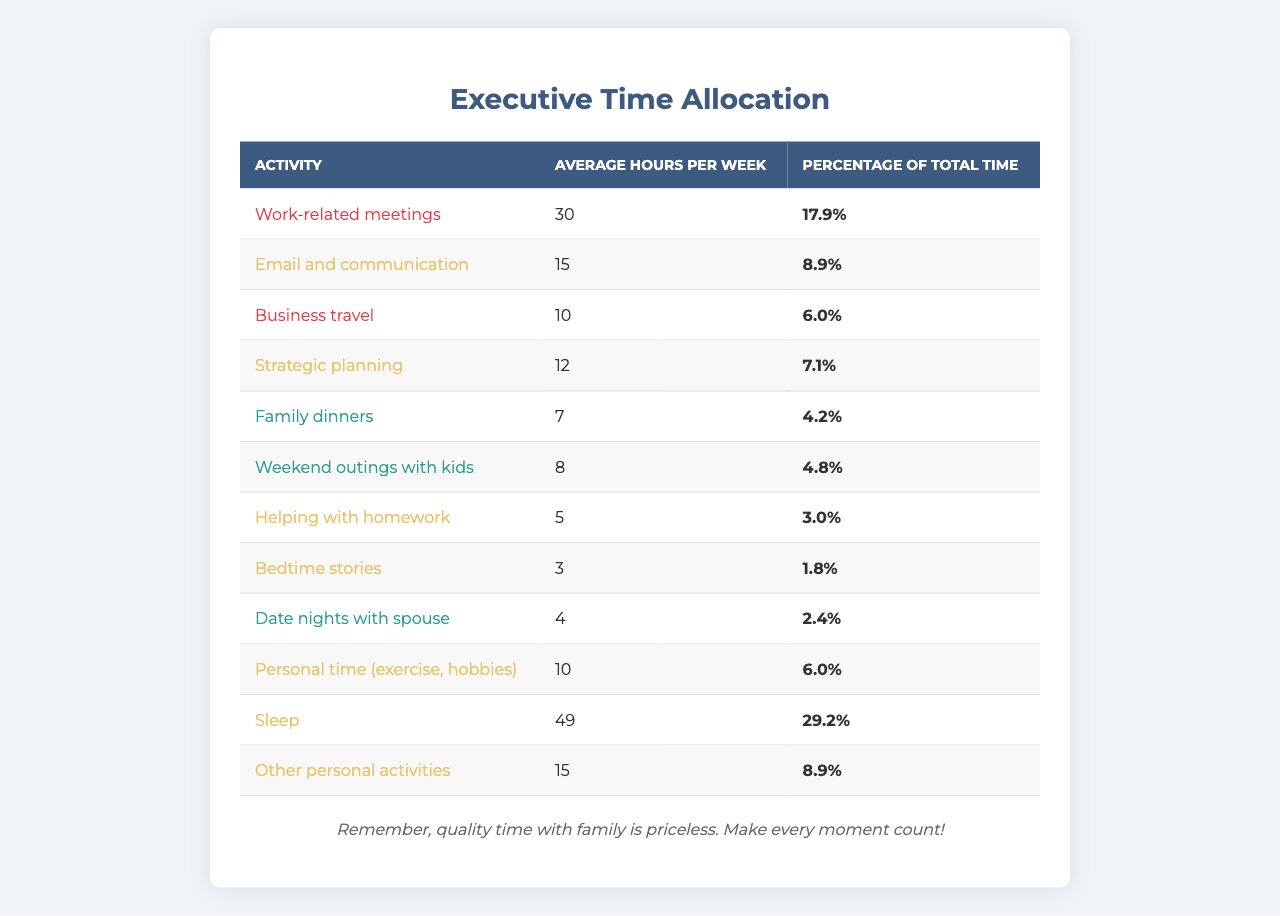What is the average number of hours spent on family dinners? The table shows that the average hours per week spent on family dinners is 7.
Answer: 7 What is the total percentage of time allocated to work-related activities? For work-related activities, the total percentage can be calculated by adding the percentages of "Work-related meetings" (17.9), "Email and communication" (8.9), "Business travel" (6.0), and "Strategic planning" (7.1), which equals 39.9%.
Answer: 39.9% How many hours per week are spent on helping with homework? The table indicates that an average of 5 hours per week is spent on helping with homework.
Answer: 5 Is the time spent on sleep greater than the time spent on personal activities? Sleep takes up 49 hours per week, while other personal activities account for 15 hours, meaning sleep is indeed greater than personal activities.
Answer: Yes What is the combined average hours spent on family activities (dinners, outings, homework, bedtime stories, and date nights)? The total for family activities is calculated by adding 7 (family dinners), 8 (weekend outings), 5 (helping with homework), 3 (bedtime stories), and 4 (date nights), which gives 27 hours.
Answer: 27 Which activity has the highest average hours spent per week? By examining the hours, sleep has the highest average at 49 hours per week.
Answer: Sleep What percentage of time is spent on personal time activities compared to family activities? Personal time is 10 hours (exercise and hobbies) and family activities total 27 hours; thus, the percentage is (10/27) * 100 ≈ 37.04%.
Answer: Approximately 37.04% How many hours per week are dedicated to work-related meetings, and what percentage of total time does this represent? Work-related meetings take 30 hours a week, which represents 17.9% of total time.
Answer: 30 hours, 17.9% What is the percentage difference between sleep and business travel time? Sleep accounts for 49 hours (29.2%) while business travel is 10 hours (6.0%), so the difference is 29.2% - 6.0% = 23.2%.
Answer: 23.2% If an executive dedicates one hour to each of the family activities per week, how many hours total would that be? Family activities count includes family dinners (1), weekend outings (1), helping with homework (1), bedtime stories (1), and date nights (1). That's a total of 5 additional hours.
Answer: 5 hours 